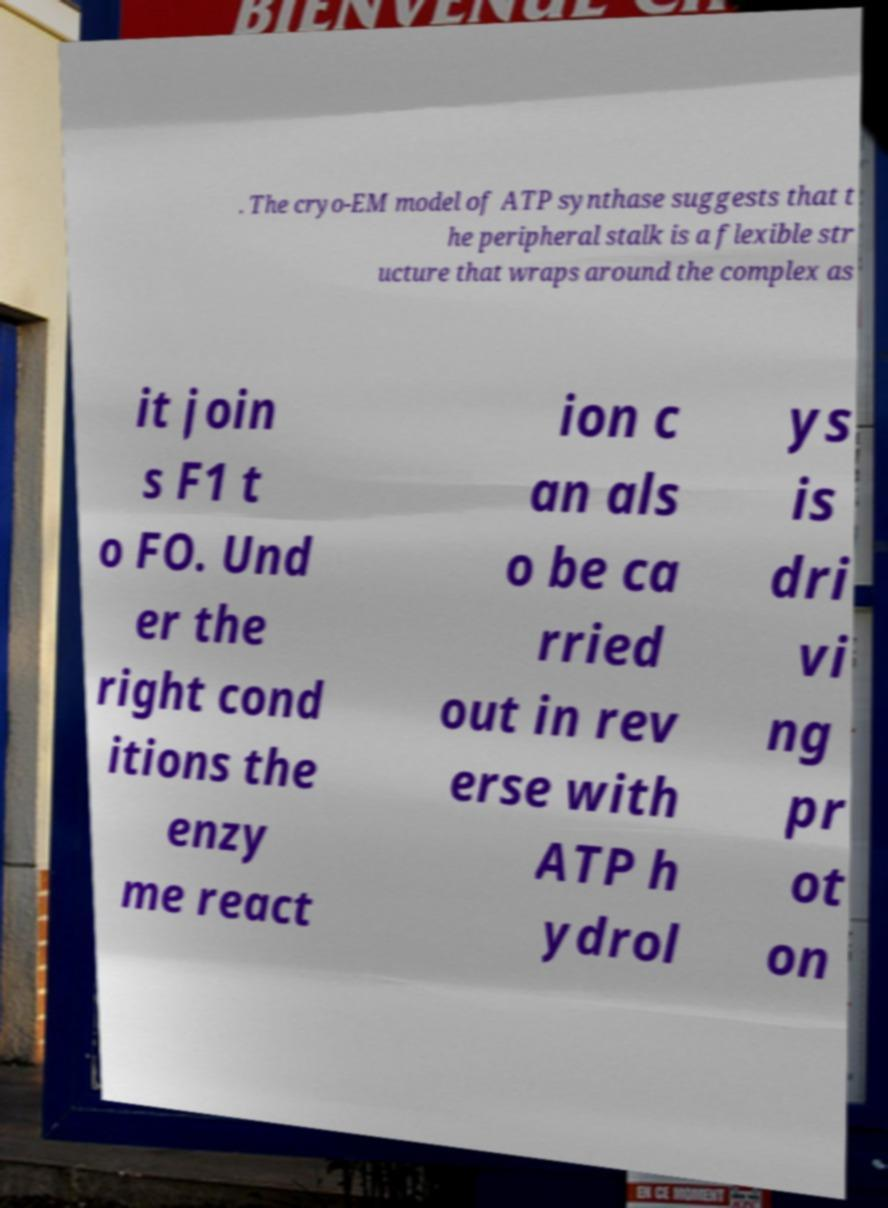Could you assist in decoding the text presented in this image and type it out clearly? . The cryo-EM model of ATP synthase suggests that t he peripheral stalk is a flexible str ucture that wraps around the complex as it join s F1 t o FO. Und er the right cond itions the enzy me react ion c an als o be ca rried out in rev erse with ATP h ydrol ys is dri vi ng pr ot on 